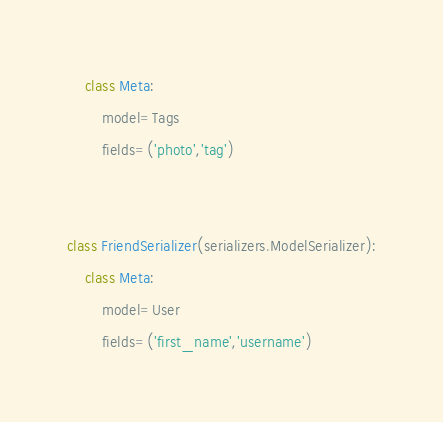Convert code to text. <code><loc_0><loc_0><loc_500><loc_500><_Python_>
    class Meta:
        model=Tags
        fields=('photo','tag')


class FriendSerializer(serializers.ModelSerializer):
    class Meta:
        model=User
        fields=('first_name','username')

</code> 